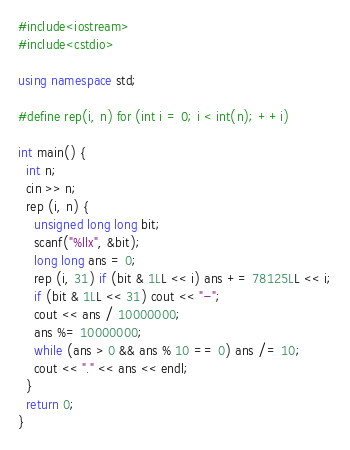Convert code to text. <code><loc_0><loc_0><loc_500><loc_500><_C++_>#include<iostream>
#include<cstdio>

using namespace std;

#define rep(i, n) for (int i = 0; i < int(n); ++i)

int main() {
  int n;
  cin >> n;
  rep (i, n) {
    unsigned long long bit;
    scanf("%llx", &bit);
    long long ans = 0;
    rep (i, 31) if (bit & 1LL << i) ans += 78125LL << i;
    if (bit & 1LL << 31) cout << "-";
    cout << ans / 10000000;
    ans %= 10000000;
    while (ans > 0 && ans % 10 == 0) ans /= 10;
    cout << "." << ans << endl;
  }
  return 0;
}</code> 